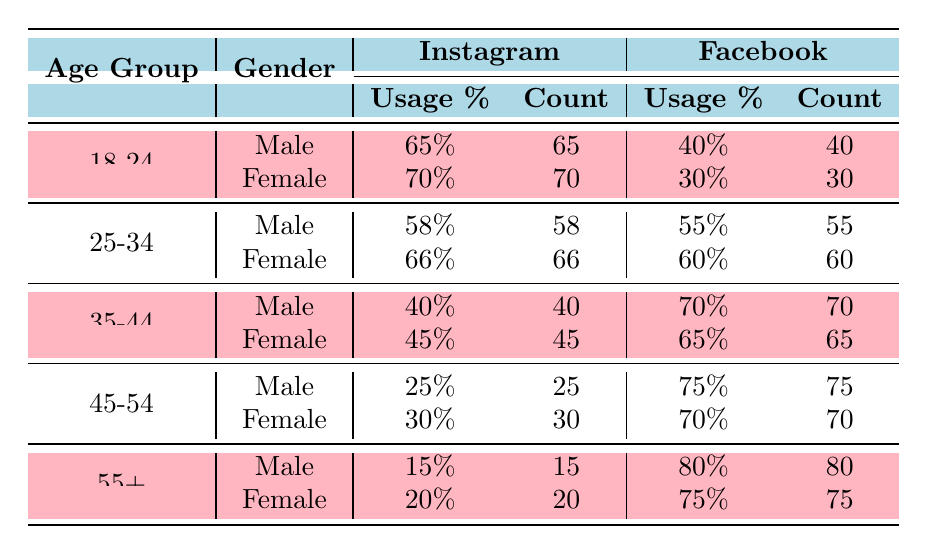What percentage of males in the age group 35-44 use Instagram? According to the table, the usage percentage of Instagram for males in the 35-44 age group is listed as 40%.
Answer: 40% What is the percentage difference in Facebook usage between females aged 18-24 and 45-54? Females aged 18-24 have a Facebook usage percentage of 30%, while those aged 45-54 have a usage percentage of 70%. The difference is 70% - 30% = 40%.
Answer: 40% Do more females aged 25-34 prefer Instagram or Facebook? The percentage of females aged 25-34 using Instagram is 66%, while the percentage using Facebook is 60%. Therefore, more females in this age group prefer Instagram.
Answer: Yes What age group shows the highest percentage of Facebook usage among males? Checking the table, males aged 45-54 have the highest Facebook usage percentage at 75%, which is greater than the percentages for all other age groups for males.
Answer: 45-54 What is the combined percentage of Instagram usage for both genders in the 18-24 age group? The usage percentage for males aged 18-24 on Instagram is 65% and for females is 70%. Adding these gives 65% + 70% = 135%.
Answer: 135% Are females in the age group 55+ less likely to use Instagram than their male counterparts? The table indicates that females aged 55+ have an Instagram usage percentage of 20%, while males have a percentage of 15%. Thus, females in this age group are more likely to use Instagram than males.
Answer: No What percentage of both genders aged 35-44 use Facebook? For males aged 35-44, the percentage is 70%, and for females, it is 65%. Adding these gives a total of 70% + 65% = 135%.
Answer: 135% Which gender has a higher Instagram usage in the age group 45-54? The table shows that males aged 45-54 have an Instagram usage of 25%, while females have 30%. Therefore, females have a higher Instagram usage in this group.
Answer: Female What is the average usage percentage of Facebook across all age groups for males? The Facebook usage percentages for males are 40%, 55%, 70%, 75%, and 80%. The sum is 40 + 55 + 70 + 75 + 80 = 320. There are 5 age groups, so the average is 320 / 5 = 64%.
Answer: 64% 